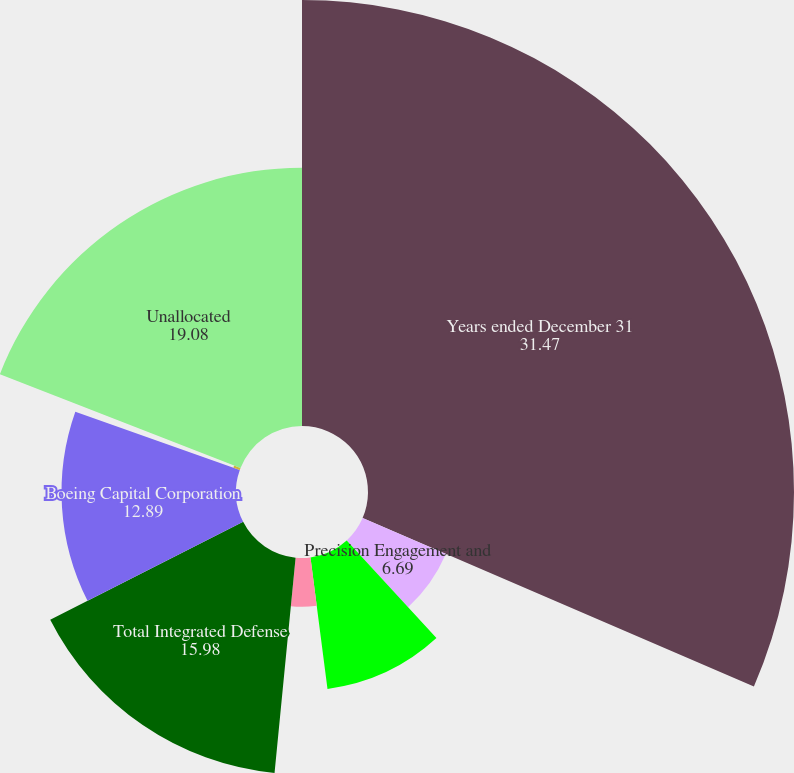Convert chart. <chart><loc_0><loc_0><loc_500><loc_500><pie_chart><fcel>Years ended December 31<fcel>Precision Engagement and<fcel>Network and Space Systems<fcel>Support Systems<fcel>Total Integrated Defense<fcel>Boeing Capital Corporation<fcel>Other<fcel>Unallocated<nl><fcel>31.47%<fcel>6.69%<fcel>9.79%<fcel>3.6%<fcel>15.98%<fcel>12.89%<fcel>0.5%<fcel>19.08%<nl></chart> 